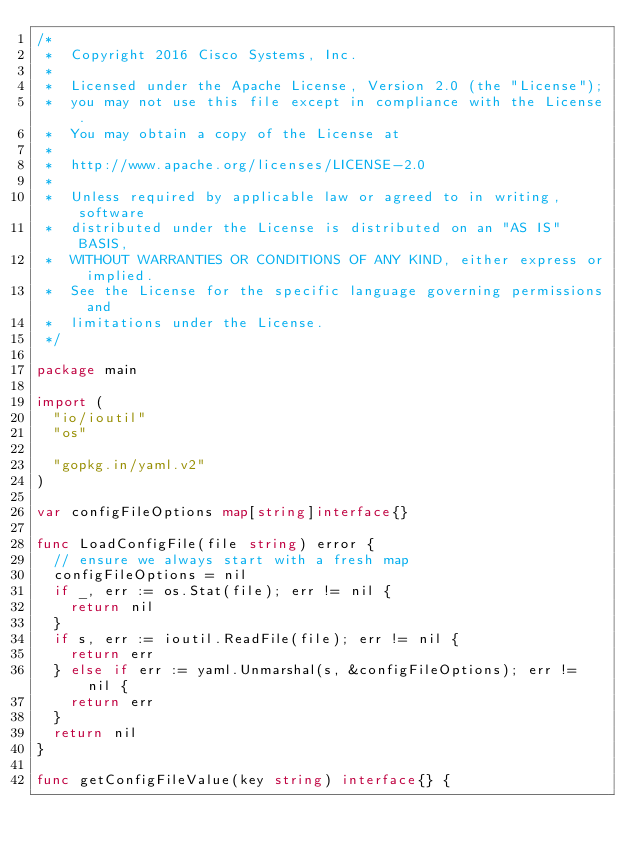<code> <loc_0><loc_0><loc_500><loc_500><_Go_>/*
 *  Copyright 2016 Cisco Systems, Inc.
 *
 *  Licensed under the Apache License, Version 2.0 (the "License");
 *  you may not use this file except in compliance with the License.
 *  You may obtain a copy of the License at
 *
 *  http://www.apache.org/licenses/LICENSE-2.0
 *
 *  Unless required by applicable law or agreed to in writing, software
 *  distributed under the License is distributed on an "AS IS" BASIS,
 *  WITHOUT WARRANTIES OR CONDITIONS OF ANY KIND, either express or implied.
 *  See the License for the specific language governing permissions and
 *  limitations under the License.
 */

package main

import (
	"io/ioutil"
	"os"

	"gopkg.in/yaml.v2"
)

var configFileOptions map[string]interface{}

func LoadConfigFile(file string) error {
	// ensure we always start with a fresh map
	configFileOptions = nil
	if _, err := os.Stat(file); err != nil {
		return nil
	}
	if s, err := ioutil.ReadFile(file); err != nil {
		return err
	} else if err := yaml.Unmarshal(s, &configFileOptions); err != nil {
		return err
	}
	return nil
}

func getConfigFileValue(key string) interface{} {</code> 